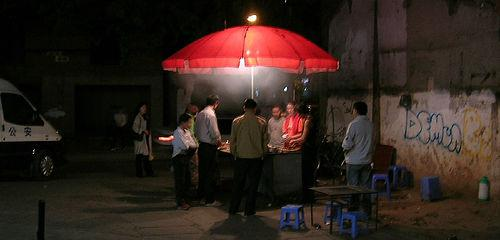Question: what color is the umbrella?
Choices:
A. Black.
B. Blue.
C. White.
D. Red.
Answer with the letter. Answer: D Question: what does the graffiti on the wall say?
Choices:
A. Die.
B. Police suck.
C. Love.
D. 'demon'.
Answer with the letter. Answer: D Question: when was this picture taken?
Choices:
A. Morning.
B. Noon.
C. Night.
D. Sunset.
Answer with the letter. Answer: C Question: what color are the stools?
Choices:
A. Blue.
B. Black.
C. Brown.
D. White.
Answer with the letter. Answer: A 